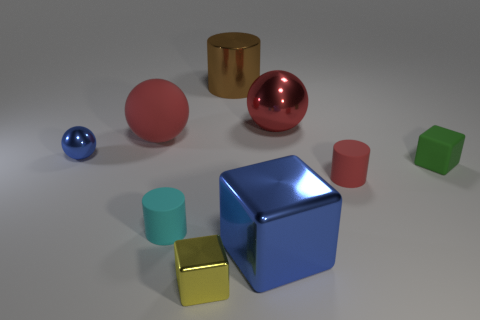Subtract all cylinders. How many objects are left? 6 Subtract all brown cylinders. Subtract all green blocks. How many objects are left? 7 Add 6 cyan cylinders. How many cyan cylinders are left? 7 Add 9 tiny cyan cylinders. How many tiny cyan cylinders exist? 10 Subtract 0 blue cylinders. How many objects are left? 9 